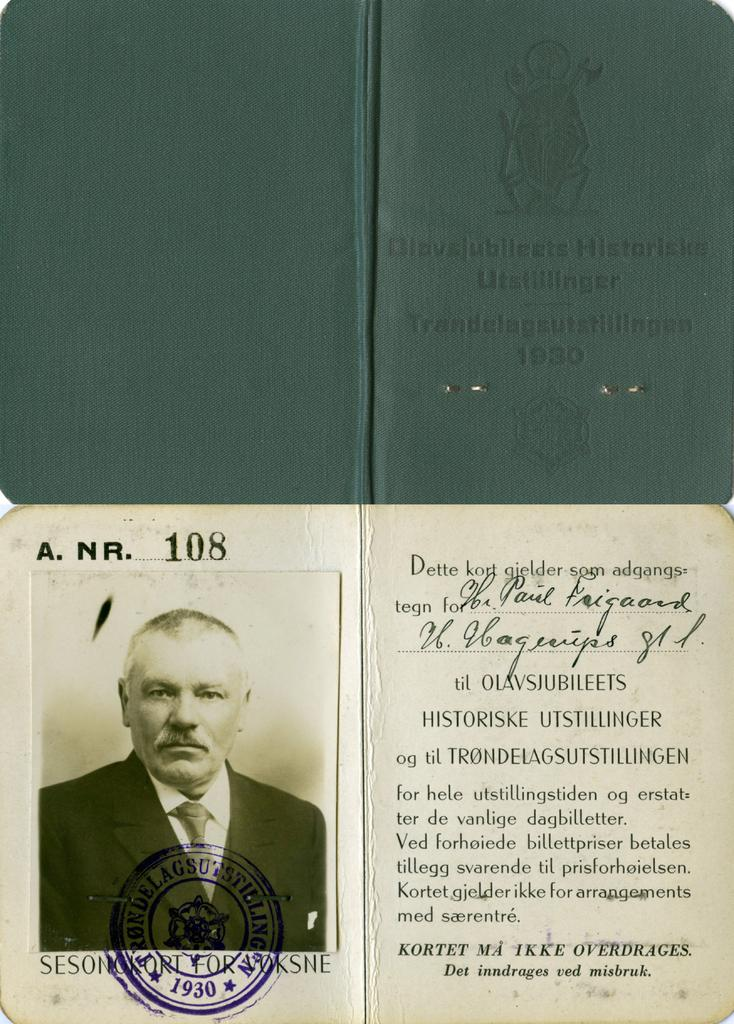Provide a one-sentence caption for the provided image. A document with a picture is stamped with the year 1930. 